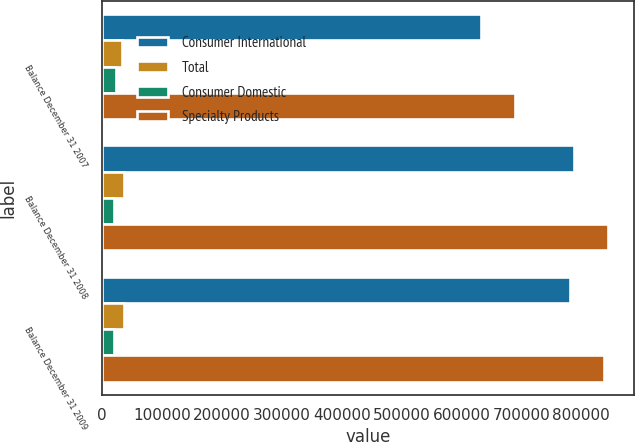Convert chart to OTSL. <chart><loc_0><loc_0><loc_500><loc_500><stacked_bar_chart><ecel><fcel>Balance December 31 2007<fcel>Balance December 31 2008<fcel>Balance December 31 2009<nl><fcel>Consumer International<fcel>633030<fcel>788516<fcel>781364<nl><fcel>Total<fcel>33224<fcel>36486<fcel>36486<nl><fcel>Consumer Domestic<fcel>22588<fcel>20228<fcel>20228<nl><fcel>Specialty Products<fcel>688842<fcel>845230<fcel>838078<nl></chart> 